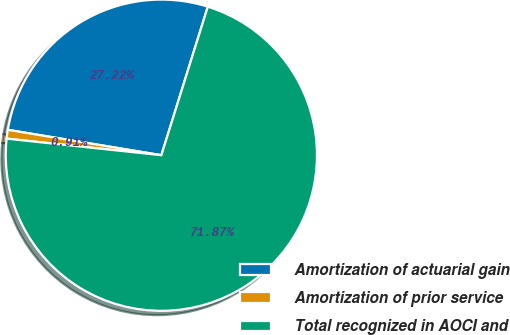Convert chart to OTSL. <chart><loc_0><loc_0><loc_500><loc_500><pie_chart><fcel>Amortization of actuarial gain<fcel>Amortization of prior service<fcel>Total recognized in AOCI and<nl><fcel>27.22%<fcel>0.91%<fcel>71.87%<nl></chart> 